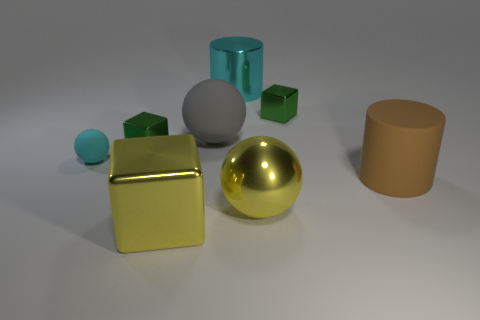What is the possible material of the blue-green cubes? The blue-green cubes appear to have a matte finish and a solid appearance, which could suggest that they are made of a material like painted wood or a matte plastic. Their lack of reflection differentiates them from the metallic objects in the composition. 